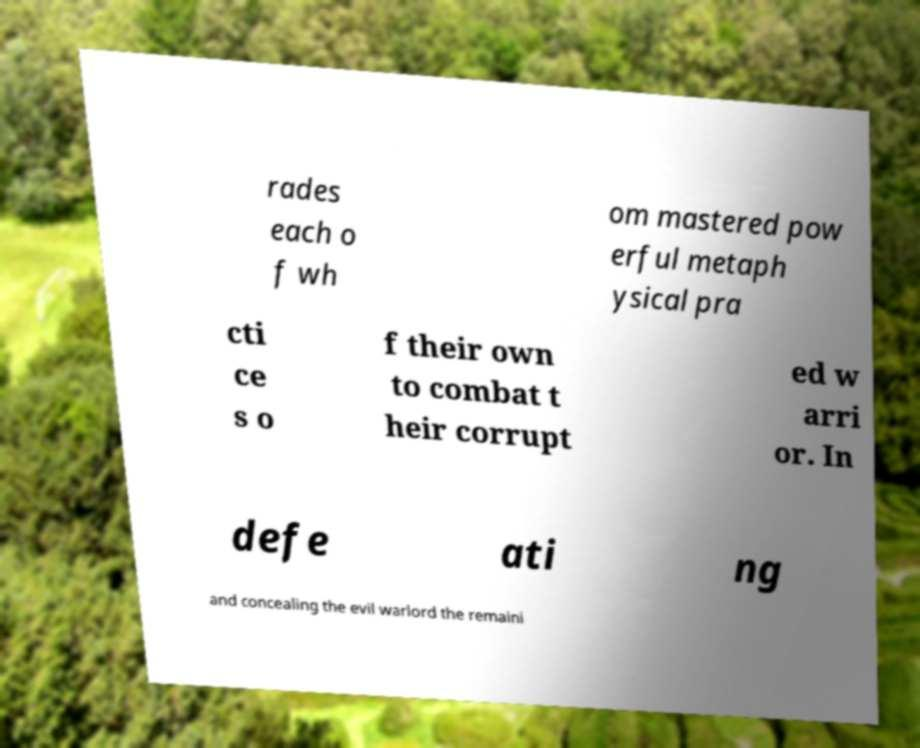For documentation purposes, I need the text within this image transcribed. Could you provide that? rades each o f wh om mastered pow erful metaph ysical pra cti ce s o f their own to combat t heir corrupt ed w arri or. In defe ati ng and concealing the evil warlord the remaini 